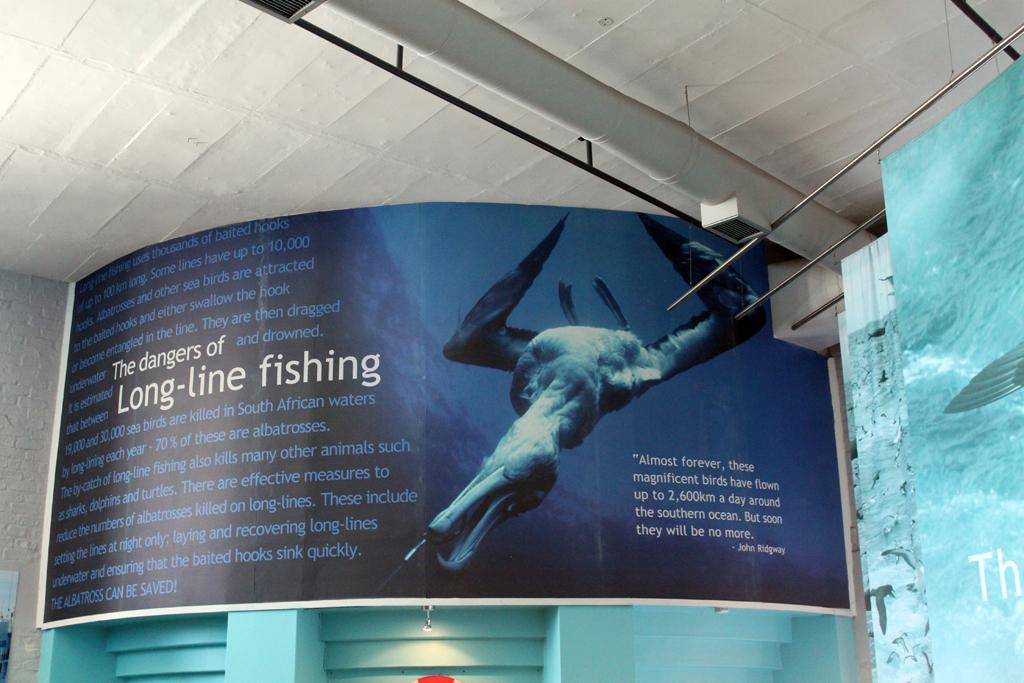What is the main object in the image? There is a banner in the image. What can be seen on the banner? The banner has an image and writing on it. Are there any other objects near the banner? Yes, there are other objects beside the banner. What type of brass instrument is being played in the image? There is no brass instrument or any indication of music being played in the image; it only features a banner with an image and writing. 